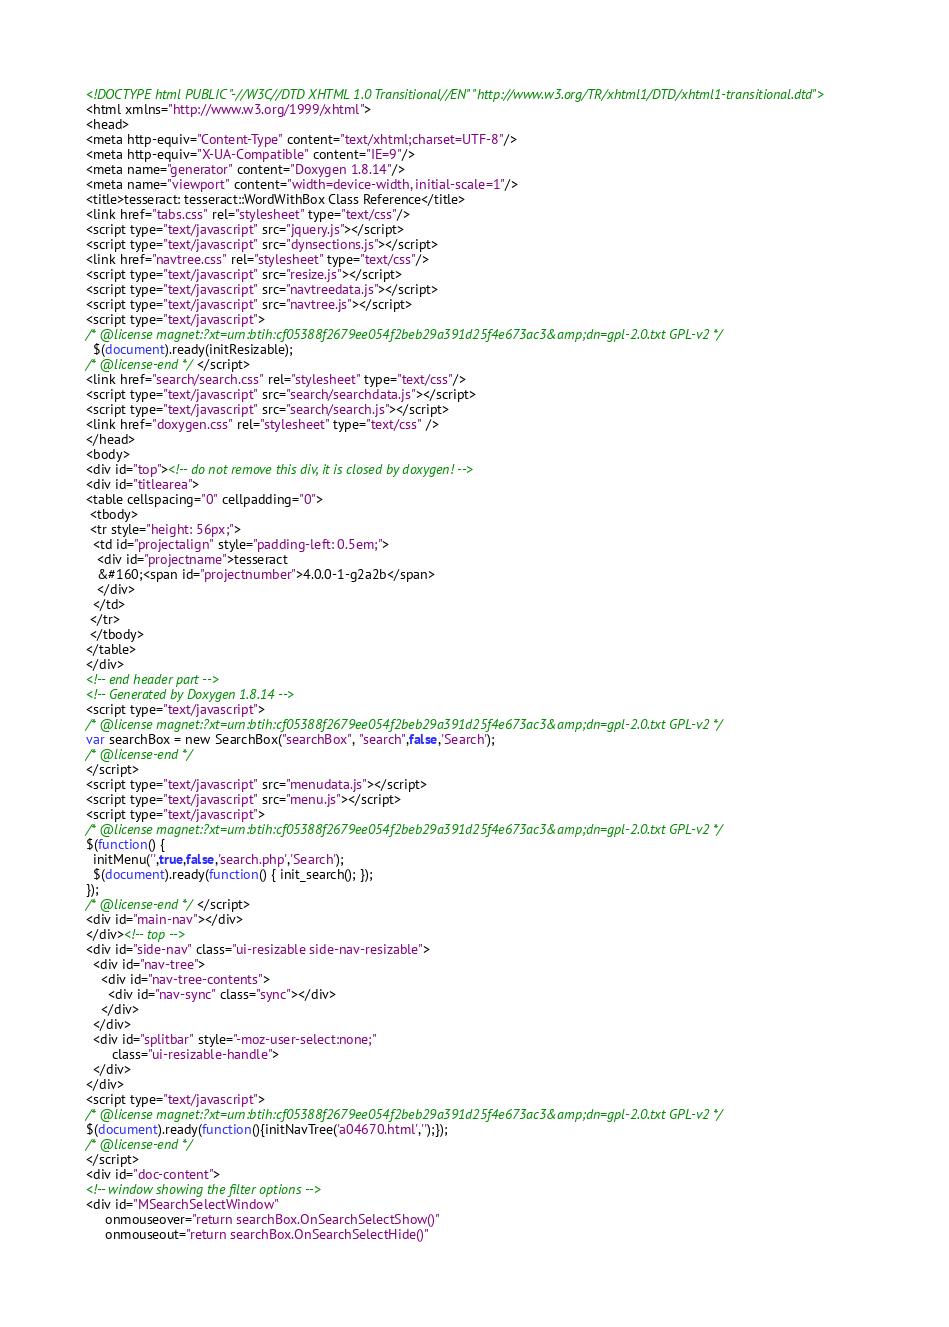<code> <loc_0><loc_0><loc_500><loc_500><_HTML_><!DOCTYPE html PUBLIC "-//W3C//DTD XHTML 1.0 Transitional//EN" "http://www.w3.org/TR/xhtml1/DTD/xhtml1-transitional.dtd">
<html xmlns="http://www.w3.org/1999/xhtml">
<head>
<meta http-equiv="Content-Type" content="text/xhtml;charset=UTF-8"/>
<meta http-equiv="X-UA-Compatible" content="IE=9"/>
<meta name="generator" content="Doxygen 1.8.14"/>
<meta name="viewport" content="width=device-width, initial-scale=1"/>
<title>tesseract: tesseract::WordWithBox Class Reference</title>
<link href="tabs.css" rel="stylesheet" type="text/css"/>
<script type="text/javascript" src="jquery.js"></script>
<script type="text/javascript" src="dynsections.js"></script>
<link href="navtree.css" rel="stylesheet" type="text/css"/>
<script type="text/javascript" src="resize.js"></script>
<script type="text/javascript" src="navtreedata.js"></script>
<script type="text/javascript" src="navtree.js"></script>
<script type="text/javascript">
/* @license magnet:?xt=urn:btih:cf05388f2679ee054f2beb29a391d25f4e673ac3&amp;dn=gpl-2.0.txt GPL-v2 */
  $(document).ready(initResizable);
/* @license-end */</script>
<link href="search/search.css" rel="stylesheet" type="text/css"/>
<script type="text/javascript" src="search/searchdata.js"></script>
<script type="text/javascript" src="search/search.js"></script>
<link href="doxygen.css" rel="stylesheet" type="text/css" />
</head>
<body>
<div id="top"><!-- do not remove this div, it is closed by doxygen! -->
<div id="titlearea">
<table cellspacing="0" cellpadding="0">
 <tbody>
 <tr style="height: 56px;">
  <td id="projectalign" style="padding-left: 0.5em;">
   <div id="projectname">tesseract
   &#160;<span id="projectnumber">4.0.0-1-g2a2b</span>
   </div>
  </td>
 </tr>
 </tbody>
</table>
</div>
<!-- end header part -->
<!-- Generated by Doxygen 1.8.14 -->
<script type="text/javascript">
/* @license magnet:?xt=urn:btih:cf05388f2679ee054f2beb29a391d25f4e673ac3&amp;dn=gpl-2.0.txt GPL-v2 */
var searchBox = new SearchBox("searchBox", "search",false,'Search');
/* @license-end */
</script>
<script type="text/javascript" src="menudata.js"></script>
<script type="text/javascript" src="menu.js"></script>
<script type="text/javascript">
/* @license magnet:?xt=urn:btih:cf05388f2679ee054f2beb29a391d25f4e673ac3&amp;dn=gpl-2.0.txt GPL-v2 */
$(function() {
  initMenu('',true,false,'search.php','Search');
  $(document).ready(function() { init_search(); });
});
/* @license-end */</script>
<div id="main-nav"></div>
</div><!-- top -->
<div id="side-nav" class="ui-resizable side-nav-resizable">
  <div id="nav-tree">
    <div id="nav-tree-contents">
      <div id="nav-sync" class="sync"></div>
    </div>
  </div>
  <div id="splitbar" style="-moz-user-select:none;" 
       class="ui-resizable-handle">
  </div>
</div>
<script type="text/javascript">
/* @license magnet:?xt=urn:btih:cf05388f2679ee054f2beb29a391d25f4e673ac3&amp;dn=gpl-2.0.txt GPL-v2 */
$(document).ready(function(){initNavTree('a04670.html','');});
/* @license-end */
</script>
<div id="doc-content">
<!-- window showing the filter options -->
<div id="MSearchSelectWindow"
     onmouseover="return searchBox.OnSearchSelectShow()"
     onmouseout="return searchBox.OnSearchSelectHide()"</code> 